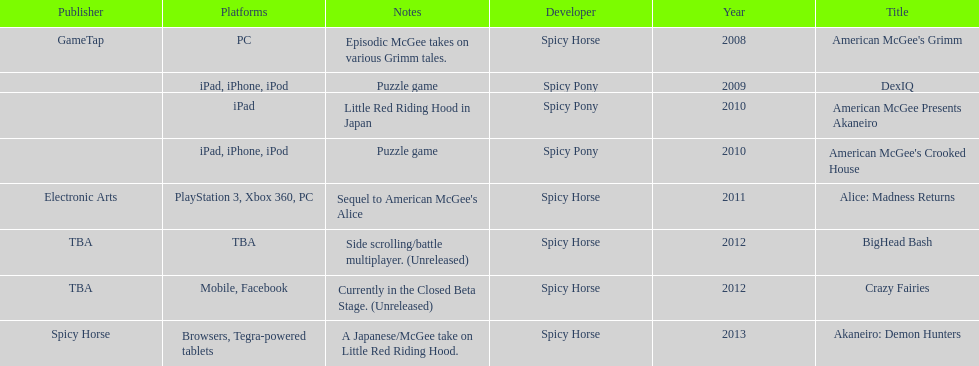How many platforms did american mcgee's grimm run on? 1. 